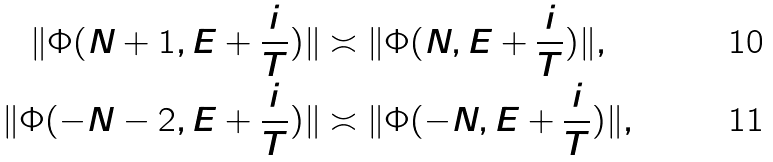<formula> <loc_0><loc_0><loc_500><loc_500>\| \Phi ( N + 1 , E + \frac { i } { T } ) \| & \asymp \| \Phi ( N , E + \frac { i } { T } ) \| , \\ \| \Phi ( - N - 2 , E + \frac { i } { T } ) \| & \asymp \| \Phi ( - N , E + \frac { i } { T } ) \| ,</formula> 